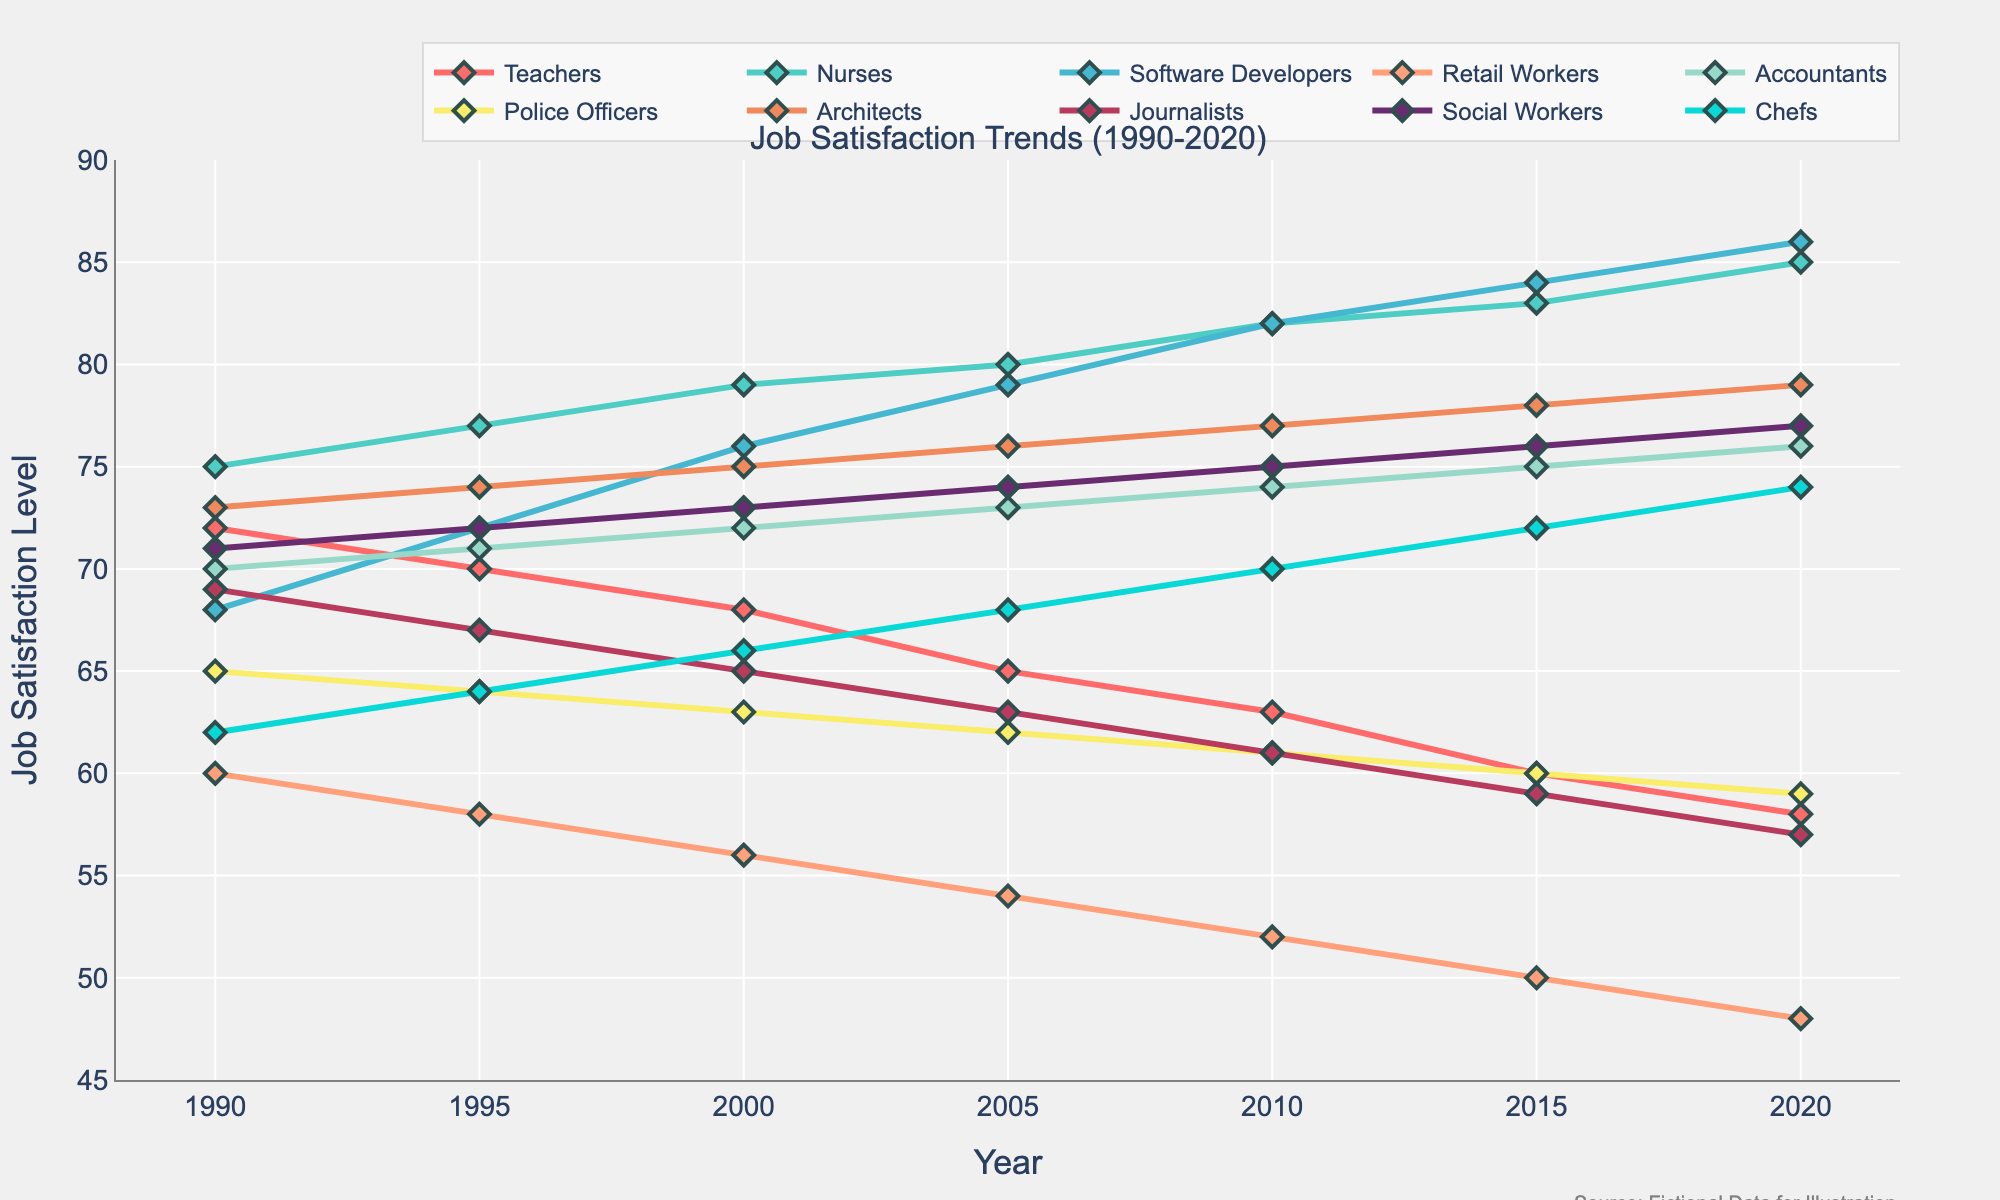what's the average job satisfaction level for Software Developers over the three decades? To find the average, sum up the job satisfaction levels for Software Developers (68 + 72 + 76 + 79 + 82 + 84 + 86) and then divide by the number of years (7). This leads to (547 / 7 = 78.14).
Answer: 78.14 Which profession showed the greatest increase in job satisfaction over the three decades? Calculate the difference between the 2020 and 1990 job satisfaction levels for each profession. The Nurses show the greatest increase: 85 - 75 = 10.
Answer: Nurses How did the job satisfaction levels for Teachers and Retail Workers compare from 1990 to 2020? Compare the job satisfaction levels of Teachers (72 in 1990 to 58 in 2020) and Retail Workers (60 in 1990 to 48 in 2020). Both professions show a decrease, but Teachers decreased by 14 points and Retail Workers by 12 points.
Answer: Teachers decreased more Which professions had stable or increasing job satisfaction levels over the three decades? Identify professions where the 2020 value is equal to or higher than the 1990 value. Nurses, Software Developers, Accountants, Architects, Social Workers, and Chefs either remained stable or increased in job satisfaction.
Answer: Nurses, Software Developers, Accountants, Architects, Social Workers, Chefs What is the overall trend in job satisfaction for Police Officers? Observe the points for Police Officers across the years from 1990 (65) to 2020 (59). The trend shows a steady decline over the three decades.
Answer: Decreasing Which professional group had the highest job satisfaction level in 2020? Look at the data points for 2020 and identify the profession with the highest value. Software Developers had the highest job satisfaction level at 86.
Answer: Software Developers What is the range of job satisfaction levels for Journalists from 1990 to 2020? Determine the difference between the highest and lowest values for Journalists between 1990 and 2020. The highest is 69 (in 1990), and the lowest is 57 (in 2020), resulting in a range of 69 - 57 = 12.
Answer: 12 Did any profession show a clear recovery or improvement in job satisfaction after an initial decline? Analyze the trends to find professions that show an initial decline followed by an improvement. Chefs have a clear recovery, starting at 62 in 1990, declining slightly mid-decade, and increasing to 74 in 2020.
Answer: Chefs 